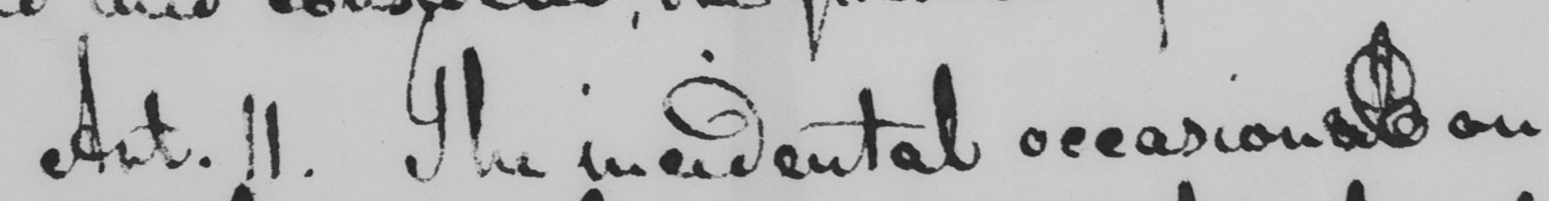Can you read and transcribe this handwriting? Art. 11. The incidental occasional on 